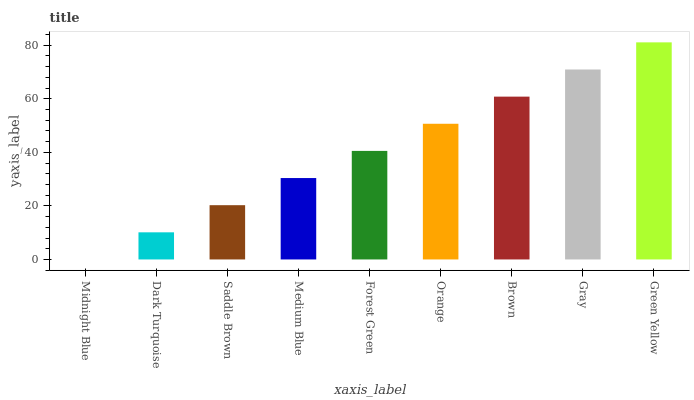Is Midnight Blue the minimum?
Answer yes or no. Yes. Is Green Yellow the maximum?
Answer yes or no. Yes. Is Dark Turquoise the minimum?
Answer yes or no. No. Is Dark Turquoise the maximum?
Answer yes or no. No. Is Dark Turquoise greater than Midnight Blue?
Answer yes or no. Yes. Is Midnight Blue less than Dark Turquoise?
Answer yes or no. Yes. Is Midnight Blue greater than Dark Turquoise?
Answer yes or no. No. Is Dark Turquoise less than Midnight Blue?
Answer yes or no. No. Is Forest Green the high median?
Answer yes or no. Yes. Is Forest Green the low median?
Answer yes or no. Yes. Is Orange the high median?
Answer yes or no. No. Is Dark Turquoise the low median?
Answer yes or no. No. 